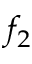Convert formula to latex. <formula><loc_0><loc_0><loc_500><loc_500>f _ { 2 }</formula> 